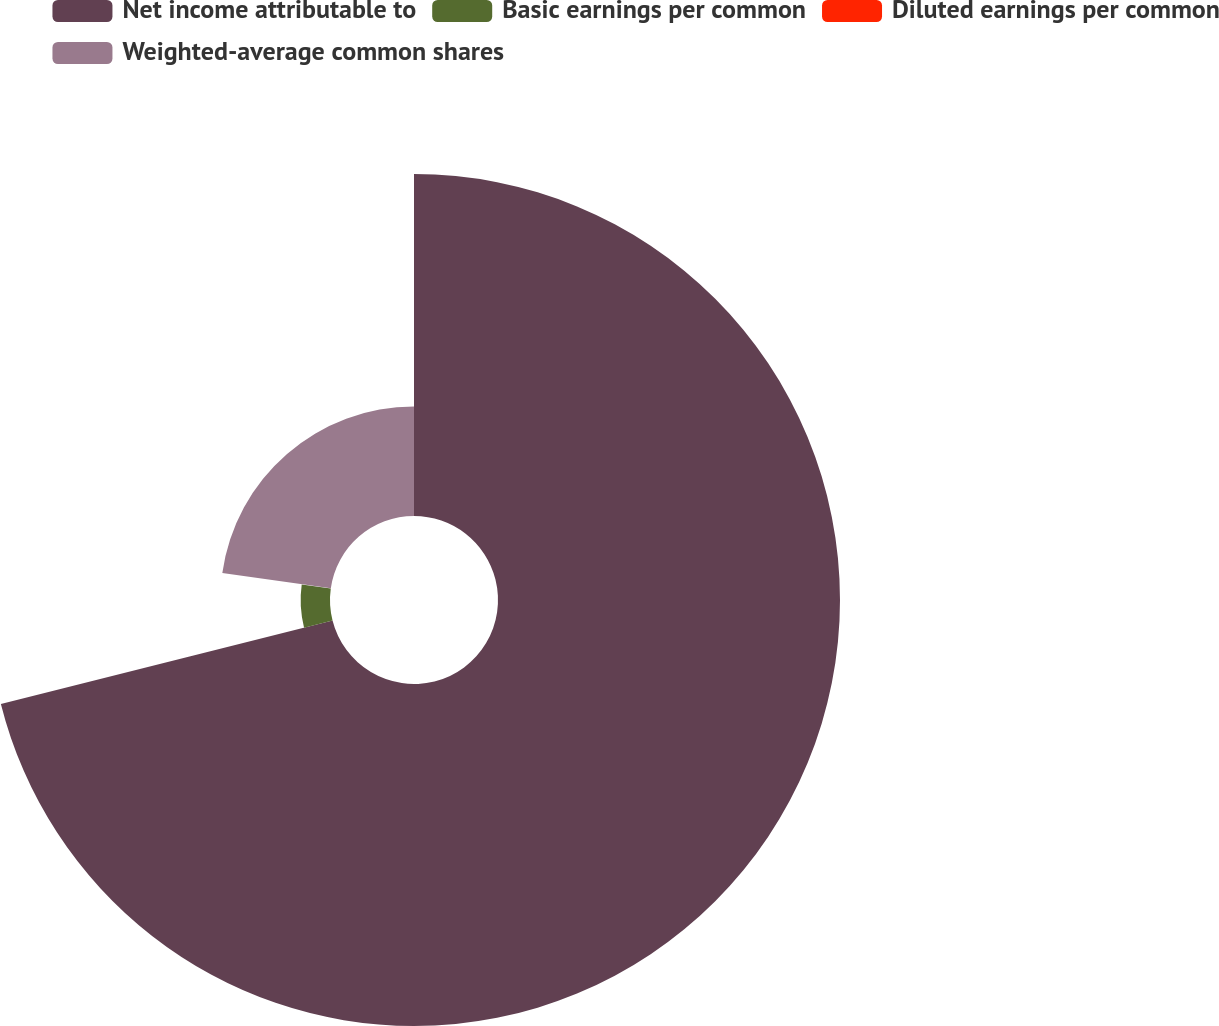Convert chart to OTSL. <chart><loc_0><loc_0><loc_500><loc_500><pie_chart><fcel>Net income attributable to<fcel>Basic earnings per common<fcel>Diluted earnings per common<fcel>Weighted-average common shares<nl><fcel>71.07%<fcel>6.1%<fcel>0.05%<fcel>22.77%<nl></chart> 